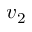<formula> <loc_0><loc_0><loc_500><loc_500>v _ { 2 }</formula> 